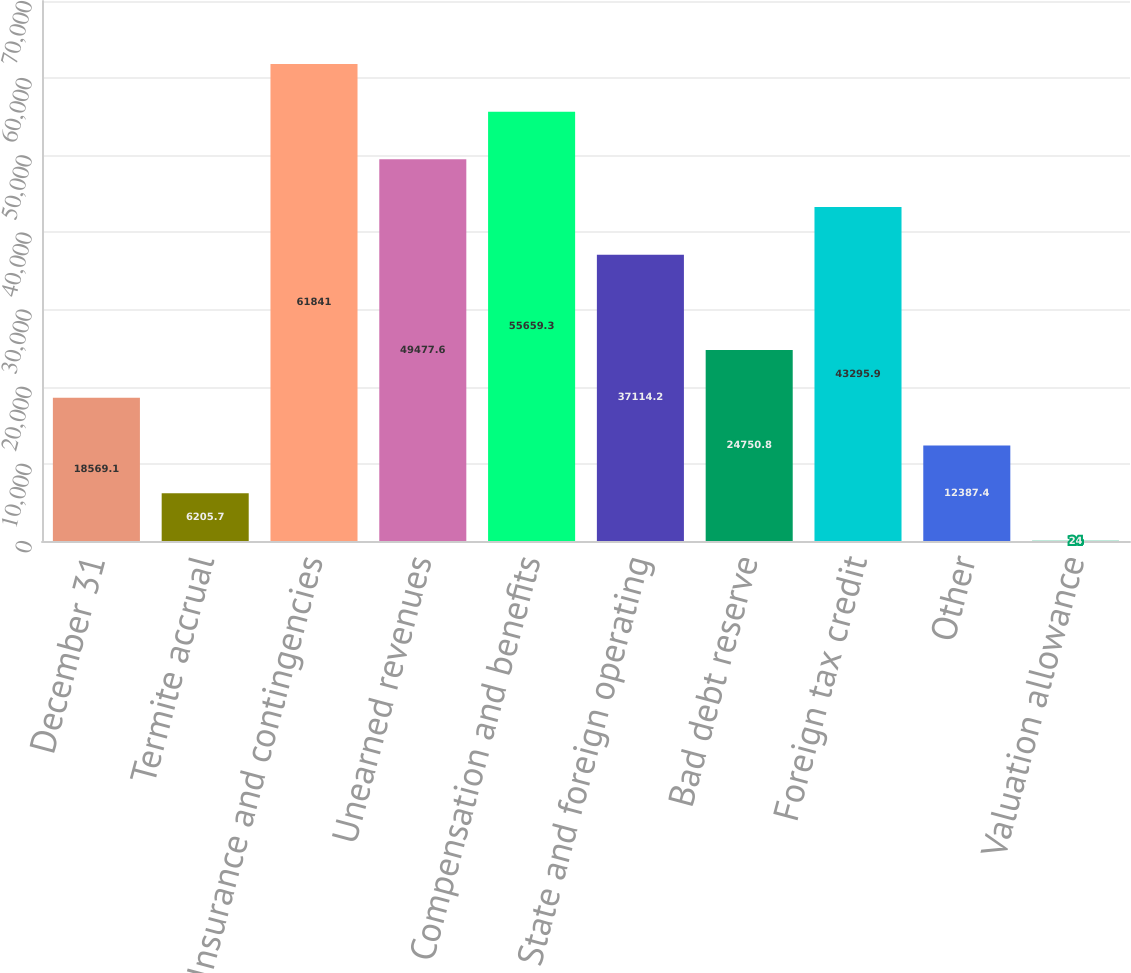<chart> <loc_0><loc_0><loc_500><loc_500><bar_chart><fcel>December 31<fcel>Termite accrual<fcel>Insurance and contingencies<fcel>Unearned revenues<fcel>Compensation and benefits<fcel>State and foreign operating<fcel>Bad debt reserve<fcel>Foreign tax credit<fcel>Other<fcel>Valuation allowance<nl><fcel>18569.1<fcel>6205.7<fcel>61841<fcel>49477.6<fcel>55659.3<fcel>37114.2<fcel>24750.8<fcel>43295.9<fcel>12387.4<fcel>24<nl></chart> 